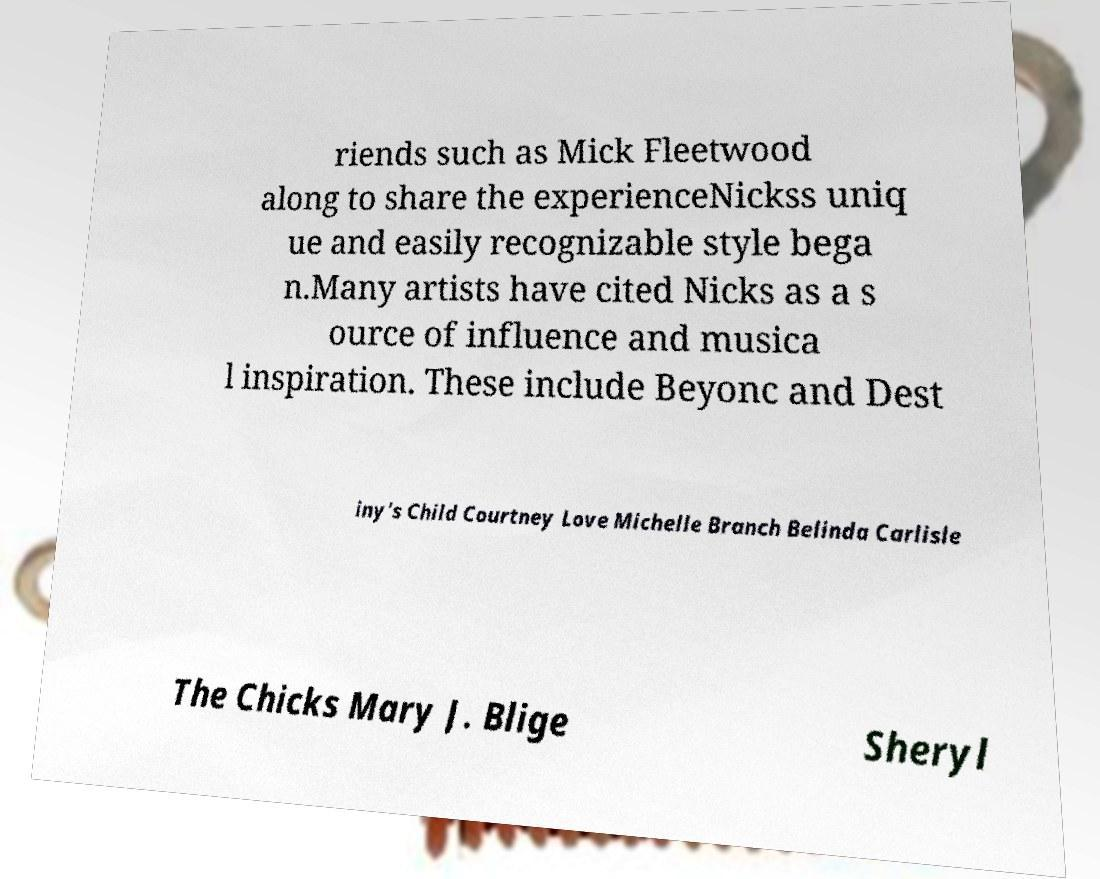Please identify and transcribe the text found in this image. riends such as Mick Fleetwood along to share the experienceNickss uniq ue and easily recognizable style bega n.Many artists have cited Nicks as a s ource of influence and musica l inspiration. These include Beyonc and Dest iny's Child Courtney Love Michelle Branch Belinda Carlisle The Chicks Mary J. Blige Sheryl 